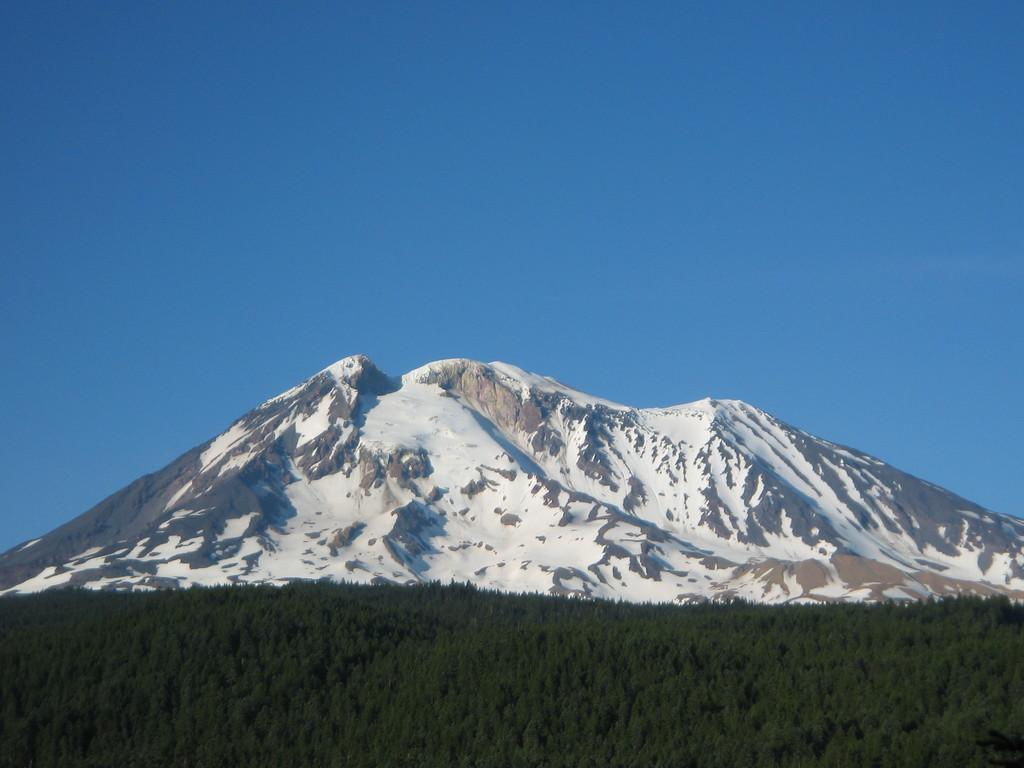What type of natural environment can be seen in the background of the image? There are trees in the background of the image. What is the main subject in the middle of the image? There is a mountain in the middle of the image. What color is the sky in the image? The sky is blue in the image. What type of sand can be seen on the mountain in the image? There is no sand present on the mountain in the image; it is a mountain, not a sandy area. What type of substance is being mined in the image? There is no mine or substance being mined present in the image. 